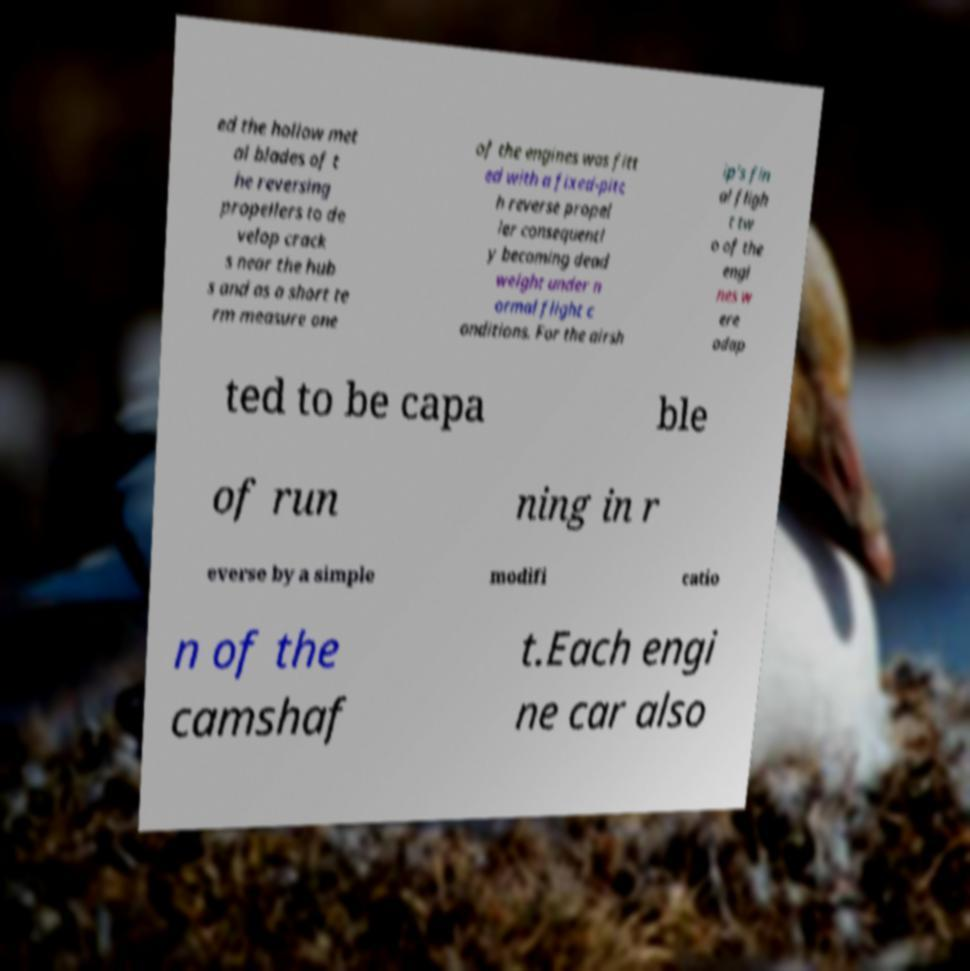Could you extract and type out the text from this image? ed the hollow met al blades of t he reversing propellers to de velop crack s near the hub s and as a short te rm measure one of the engines was fitt ed with a fixed-pitc h reverse propel ler consequentl y becoming dead weight under n ormal flight c onditions. For the airsh ip's fin al fligh t tw o of the engi nes w ere adap ted to be capa ble of run ning in r everse by a simple modifi catio n of the camshaf t.Each engi ne car also 